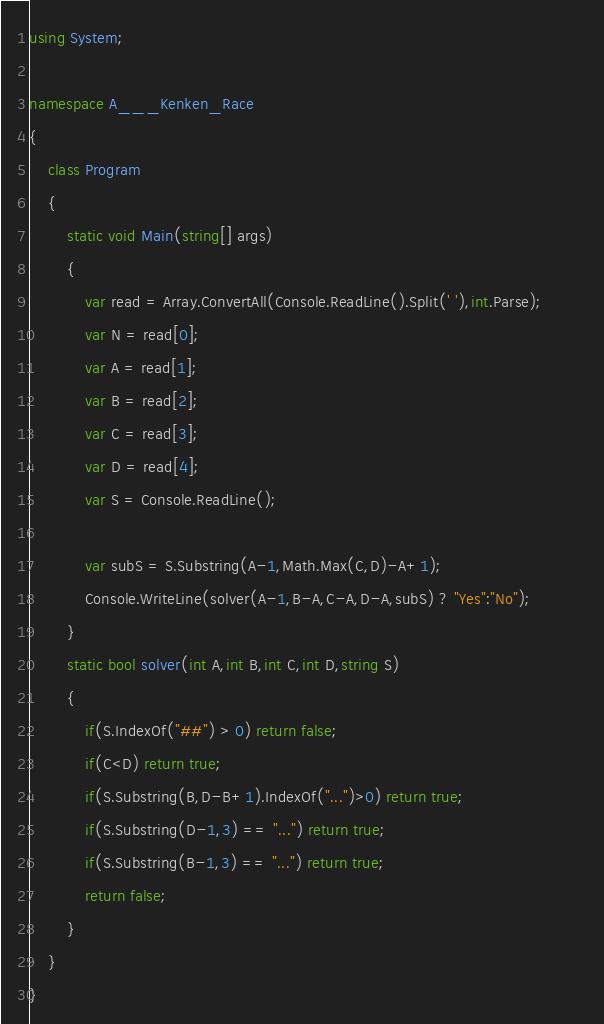Convert code to text. <code><loc_0><loc_0><loc_500><loc_500><_C#_>using System;

namespace A___Kenken_Race
{
    class Program
    {
        static void Main(string[] args)
        {
            var read = Array.ConvertAll(Console.ReadLine().Split(' '),int.Parse);
            var N = read[0];
            var A = read[1];
            var B = read[2];
            var C = read[3];
            var D = read[4];
            var S = Console.ReadLine();

            var subS = S.Substring(A-1,Math.Max(C,D)-A+1);
            Console.WriteLine(solver(A-1,B-A,C-A,D-A,subS) ? "Yes":"No");            
        }
        static bool solver(int A,int B,int C,int D,string S)
        {
            if(S.IndexOf("##") > 0) return false;
            if(C<D) return true;
            if(S.Substring(B,D-B+1).IndexOf("...")>0) return true;
            if(S.Substring(D-1,3) == "...") return true;
            if(S.Substring(B-1,3) == "...") return true;
            return false;
        }
    }
}
</code> 